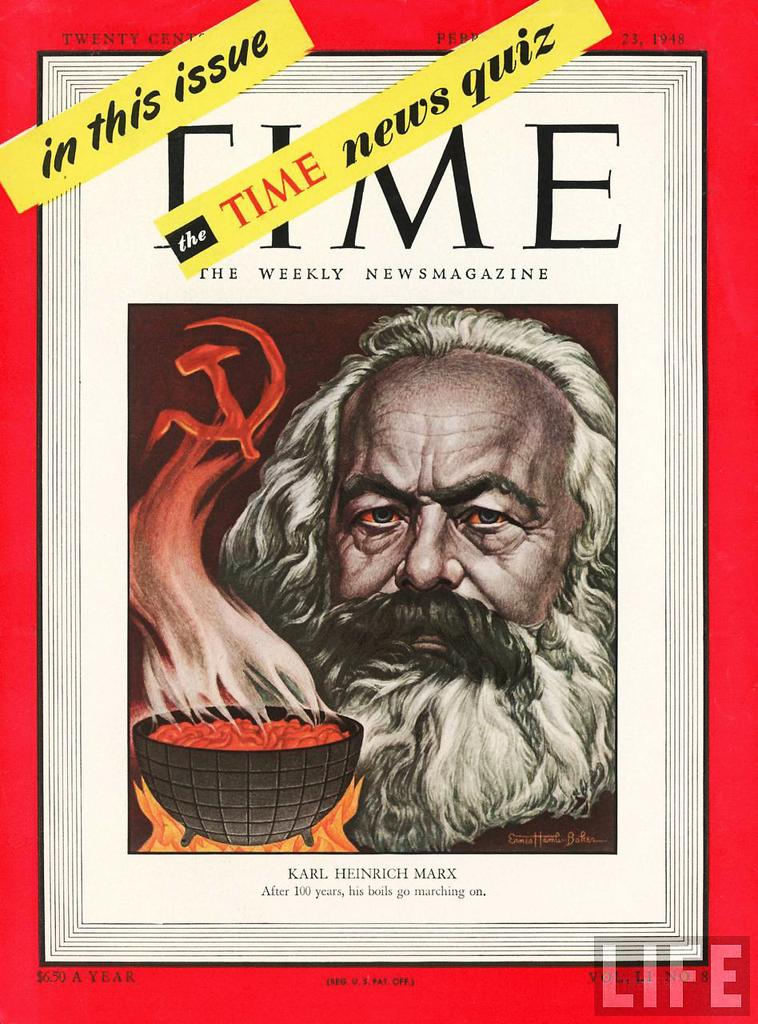<image>
Relay a brief, clear account of the picture shown. A Time Magazine issue about Karl Marx also includes a news quiz. 